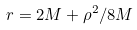<formula> <loc_0><loc_0><loc_500><loc_500>r = 2 M + \rho ^ { 2 } / 8 M</formula> 